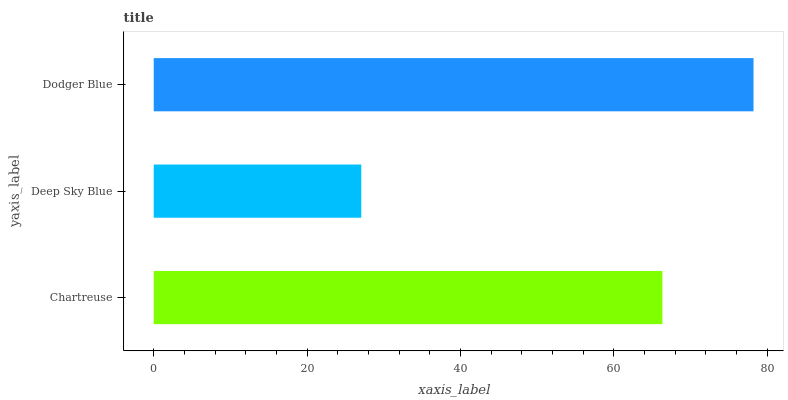Is Deep Sky Blue the minimum?
Answer yes or no. Yes. Is Dodger Blue the maximum?
Answer yes or no. Yes. Is Dodger Blue the minimum?
Answer yes or no. No. Is Deep Sky Blue the maximum?
Answer yes or no. No. Is Dodger Blue greater than Deep Sky Blue?
Answer yes or no. Yes. Is Deep Sky Blue less than Dodger Blue?
Answer yes or no. Yes. Is Deep Sky Blue greater than Dodger Blue?
Answer yes or no. No. Is Dodger Blue less than Deep Sky Blue?
Answer yes or no. No. Is Chartreuse the high median?
Answer yes or no. Yes. Is Chartreuse the low median?
Answer yes or no. Yes. Is Dodger Blue the high median?
Answer yes or no. No. Is Dodger Blue the low median?
Answer yes or no. No. 